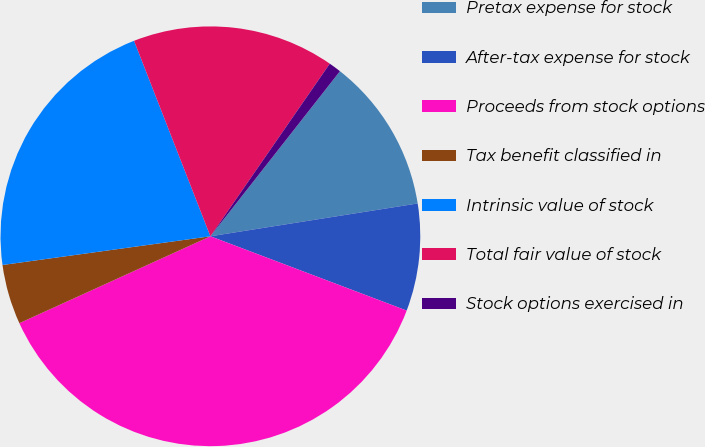<chart> <loc_0><loc_0><loc_500><loc_500><pie_chart><fcel>Pretax expense for stock<fcel>After-tax expense for stock<fcel>Proceeds from stock options<fcel>Tax benefit classified in<fcel>Intrinsic value of stock<fcel>Total fair value of stock<fcel>Stock options exercised in<nl><fcel>11.91%<fcel>8.26%<fcel>37.45%<fcel>4.61%<fcel>21.26%<fcel>15.56%<fcel>0.96%<nl></chart> 